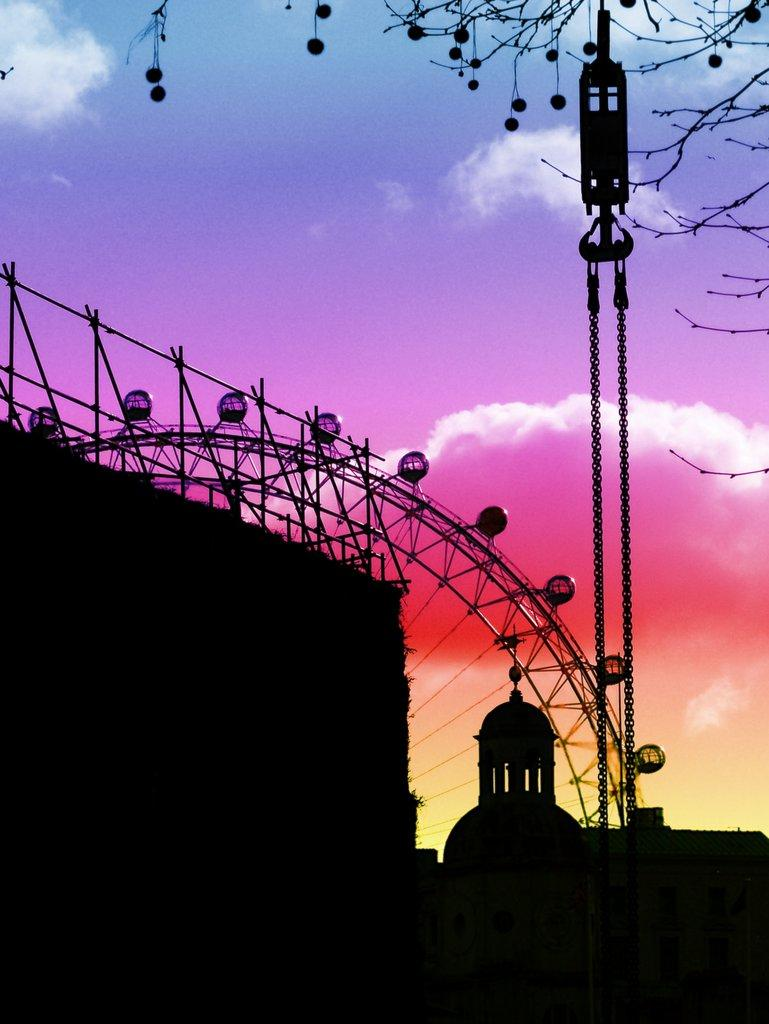What is the main structure visible in the image? There is a Ferris wheel in the image. What object can be seen connecting the Ferris wheel to the ground? There is a chain in the image. What type of natural element is present in the image? There is a tree in the image. What type of man-made structure is visible in the image? There is a building in the image. What is the condition of the sky in the image? The sky is cloudy in the image. Can you see any keys hanging from the Ferris wheel in the image? There are no keys visible hanging from the Ferris wheel in the image. Are there any giants or snails present in the image? There are no giants or snails present in the image. 